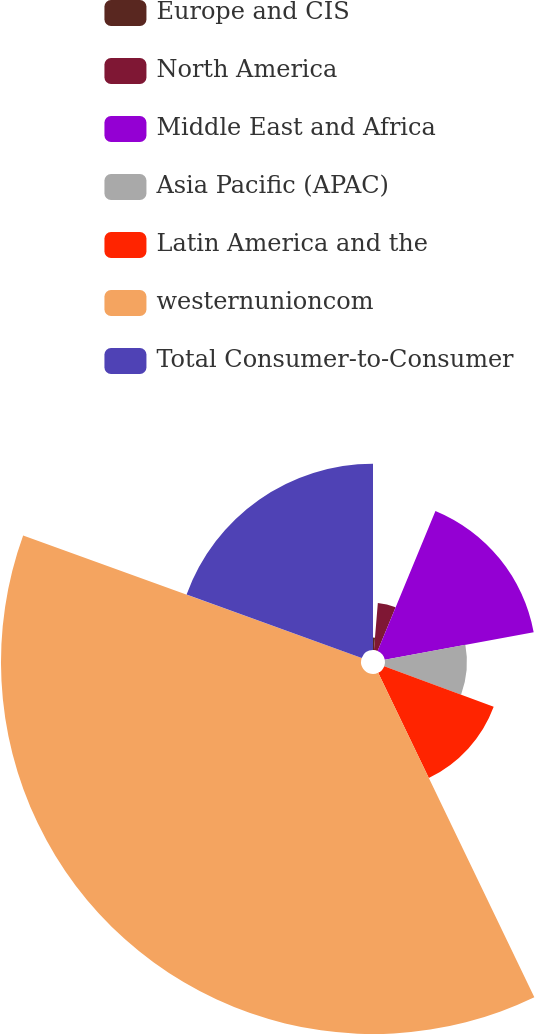Convert chart to OTSL. <chart><loc_0><loc_0><loc_500><loc_500><pie_chart><fcel>Europe and CIS<fcel>North America<fcel>Middle East and Africa<fcel>Asia Pacific (APAC)<fcel>Latin America and the<fcel>westernunioncom<fcel>Total Consumer-to-Consumer<nl><fcel>1.3%<fcel>4.94%<fcel>15.84%<fcel>8.57%<fcel>12.21%<fcel>37.66%<fcel>19.48%<nl></chart> 